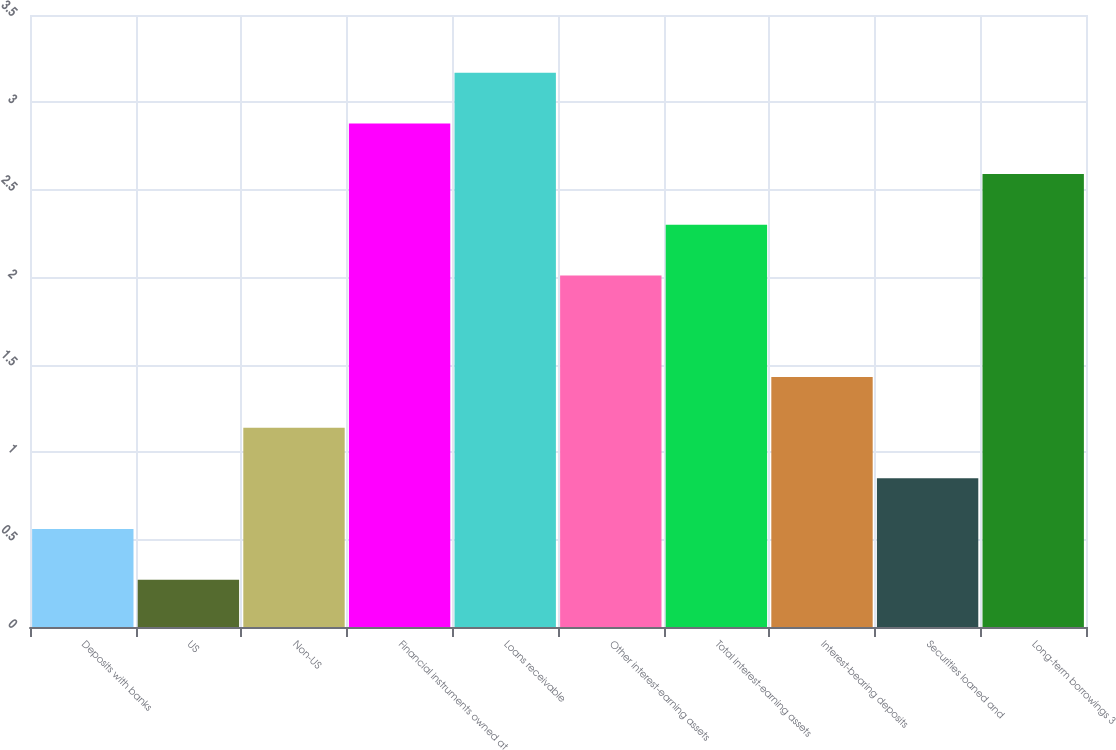Convert chart to OTSL. <chart><loc_0><loc_0><loc_500><loc_500><bar_chart><fcel>Deposits with banks<fcel>US<fcel>Non-US<fcel>Financial instruments owned at<fcel>Loans receivable<fcel>Other interest-earning assets<fcel>Total interest-earning assets<fcel>Interest-bearing deposits<fcel>Securities loaned and<fcel>Long-term borrowings 3<nl><fcel>0.56<fcel>0.27<fcel>1.14<fcel>2.88<fcel>3.17<fcel>2.01<fcel>2.3<fcel>1.43<fcel>0.85<fcel>2.59<nl></chart> 